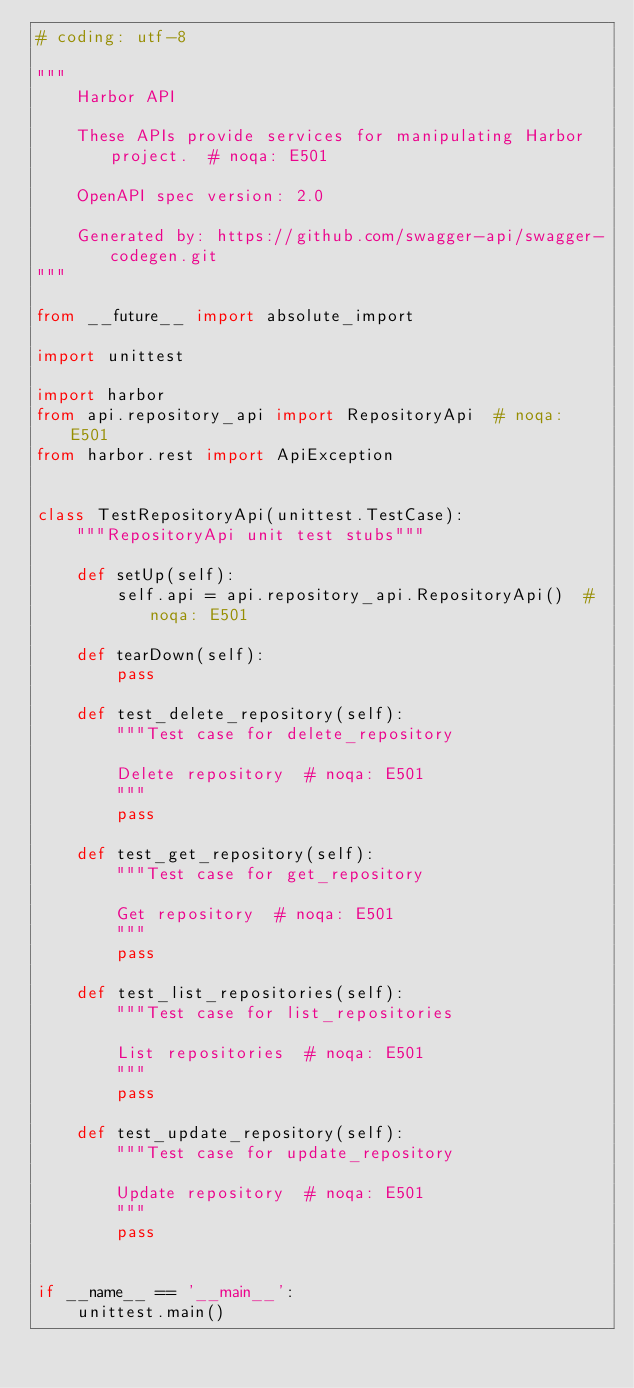<code> <loc_0><loc_0><loc_500><loc_500><_Python_># coding: utf-8

"""
    Harbor API

    These APIs provide services for manipulating Harbor project.  # noqa: E501

    OpenAPI spec version: 2.0
    
    Generated by: https://github.com/swagger-api/swagger-codegen.git
"""

from __future__ import absolute_import

import unittest

import harbor
from api.repository_api import RepositoryApi  # noqa: E501
from harbor.rest import ApiException


class TestRepositoryApi(unittest.TestCase):
    """RepositoryApi unit test stubs"""

    def setUp(self):
        self.api = api.repository_api.RepositoryApi()  # noqa: E501

    def tearDown(self):
        pass

    def test_delete_repository(self):
        """Test case for delete_repository

        Delete repository  # noqa: E501
        """
        pass

    def test_get_repository(self):
        """Test case for get_repository

        Get repository  # noqa: E501
        """
        pass

    def test_list_repositories(self):
        """Test case for list_repositories

        List repositories  # noqa: E501
        """
        pass

    def test_update_repository(self):
        """Test case for update_repository

        Update repository  # noqa: E501
        """
        pass


if __name__ == '__main__':
    unittest.main()
</code> 